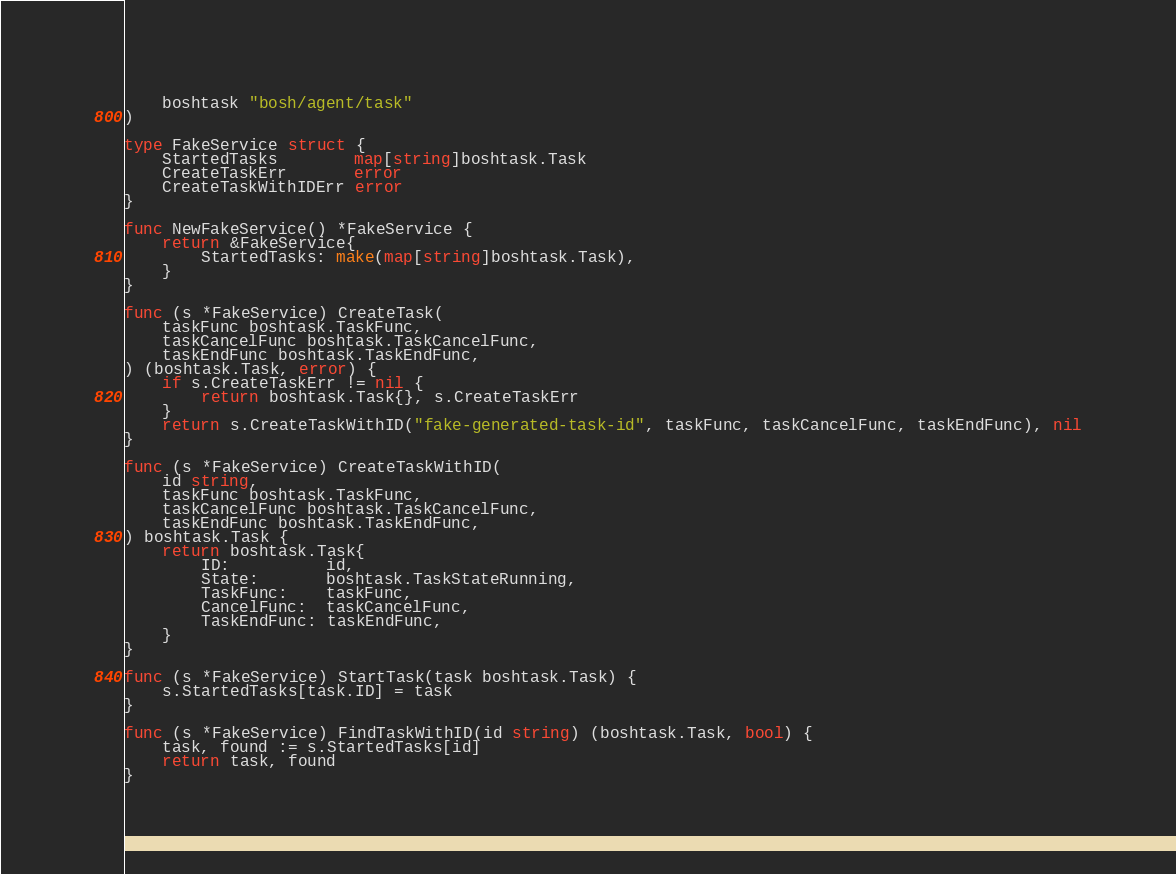<code> <loc_0><loc_0><loc_500><loc_500><_Go_>	boshtask "bosh/agent/task"
)

type FakeService struct {
	StartedTasks        map[string]boshtask.Task
	CreateTaskErr       error
	CreateTaskWithIDErr error
}

func NewFakeService() *FakeService {
	return &FakeService{
		StartedTasks: make(map[string]boshtask.Task),
	}
}

func (s *FakeService) CreateTask(
	taskFunc boshtask.TaskFunc,
	taskCancelFunc boshtask.TaskCancelFunc,
	taskEndFunc boshtask.TaskEndFunc,
) (boshtask.Task, error) {
	if s.CreateTaskErr != nil {
		return boshtask.Task{}, s.CreateTaskErr
	}
	return s.CreateTaskWithID("fake-generated-task-id", taskFunc, taskCancelFunc, taskEndFunc), nil
}

func (s *FakeService) CreateTaskWithID(
	id string,
	taskFunc boshtask.TaskFunc,
	taskCancelFunc boshtask.TaskCancelFunc,
	taskEndFunc boshtask.TaskEndFunc,
) boshtask.Task {
	return boshtask.Task{
		ID:          id,
		State:       boshtask.TaskStateRunning,
		TaskFunc:    taskFunc,
		CancelFunc:  taskCancelFunc,
		TaskEndFunc: taskEndFunc,
	}
}

func (s *FakeService) StartTask(task boshtask.Task) {
	s.StartedTasks[task.ID] = task
}

func (s *FakeService) FindTaskWithID(id string) (boshtask.Task, bool) {
	task, found := s.StartedTasks[id]
	return task, found
}
</code> 